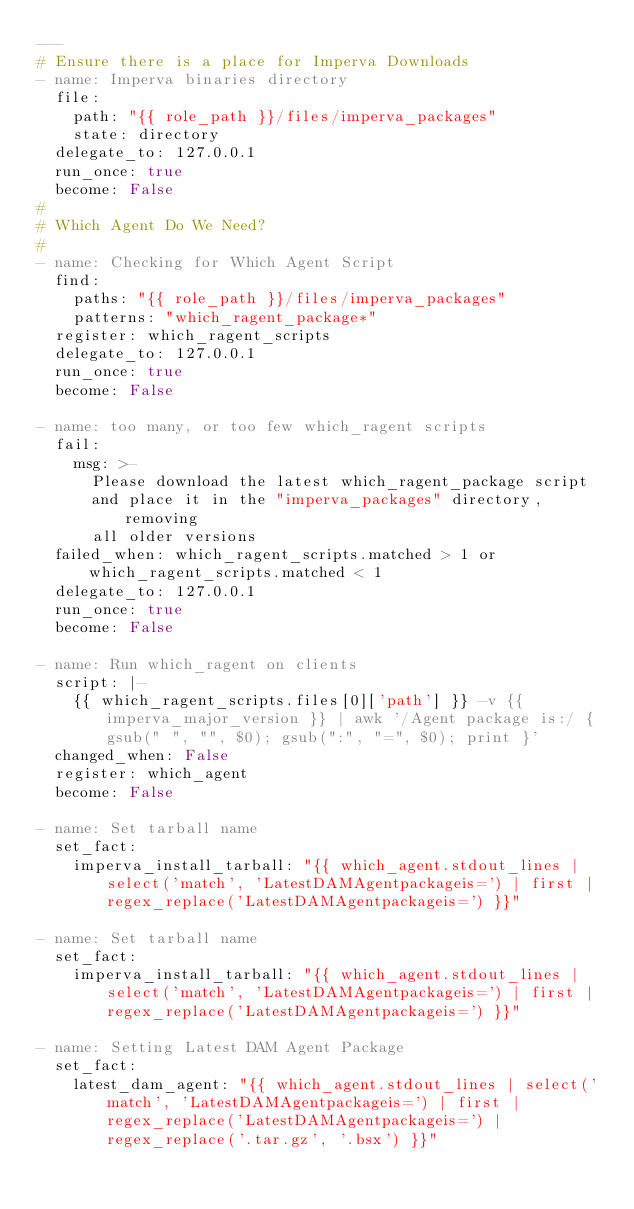<code> <loc_0><loc_0><loc_500><loc_500><_YAML_>---
# Ensure there is a place for Imperva Downloads
- name: Imperva binaries directory
  file:
    path: "{{ role_path }}/files/imperva_packages"
    state: directory
  delegate_to: 127.0.0.1
  run_once: true
  become: False
#
# Which Agent Do We Need?
#
- name: Checking for Which Agent Script
  find:
    paths: "{{ role_path }}/files/imperva_packages"
    patterns: "which_ragent_package*"
  register: which_ragent_scripts
  delegate_to: 127.0.0.1
  run_once: true
  become: False

- name: too many, or too few which_ragent scripts
  fail:
    msg: >-
      Please download the latest which_ragent_package script
      and place it in the "imperva_packages" directory, removing
      all older versions
  failed_when: which_ragent_scripts.matched > 1 or which_ragent_scripts.matched < 1
  delegate_to: 127.0.0.1
  run_once: true
  become: False

- name: Run which_ragent on clients
  script: |-
    {{ which_ragent_scripts.files[0]['path'] }} -v {{ imperva_major_version }} | awk '/Agent package is:/ { gsub(" ", "", $0); gsub(":", "=", $0); print }'
  changed_when: False
  register: which_agent
  become: False

- name: Set tarball name
  set_fact:
    imperva_install_tarball: "{{ which_agent.stdout_lines | select('match', 'LatestDAMAgentpackageis=') | first | regex_replace('LatestDAMAgentpackageis=') }}"

- name: Set tarball name
  set_fact:
    imperva_install_tarball: "{{ which_agent.stdout_lines | select('match', 'LatestDAMAgentpackageis=') | first | regex_replace('LatestDAMAgentpackageis=') }}"

- name: Setting Latest DAM Agent Package
  set_fact:
    latest_dam_agent: "{{ which_agent.stdout_lines | select('match', 'LatestDAMAgentpackageis=') | first | regex_replace('LatestDAMAgentpackageis=') | regex_replace('.tar.gz', '.bsx') }}"
</code> 